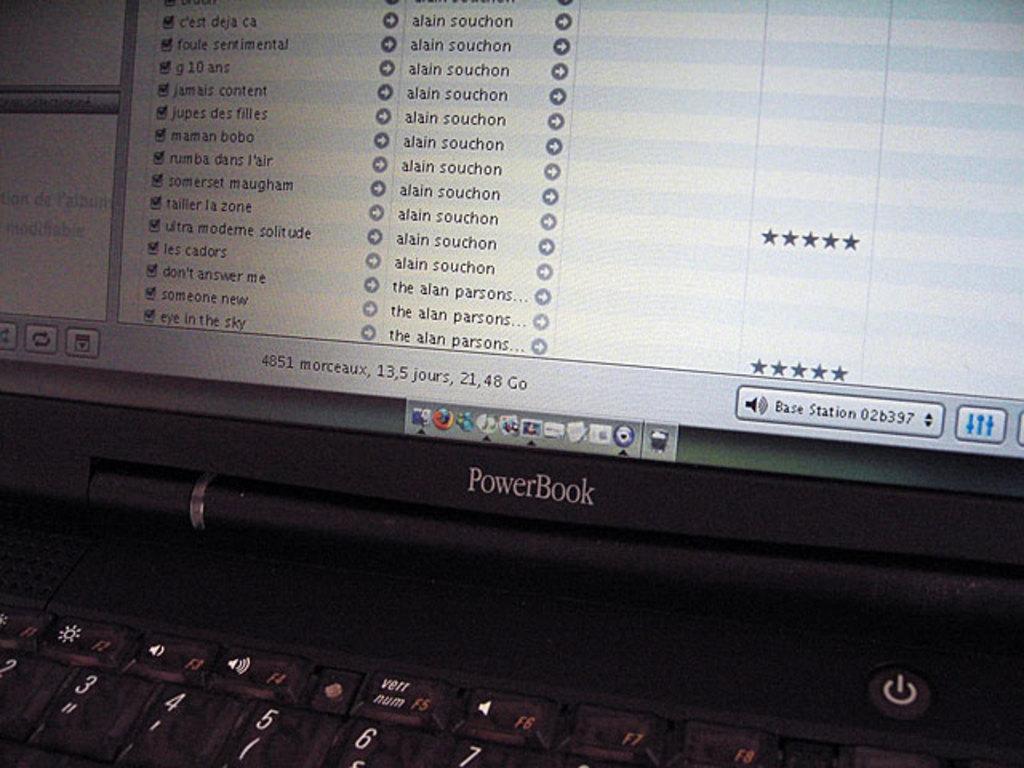In one or two sentences, can you explain what this image depicts? In the image in the center there is a laptop. And we can see a few apps on the screen. 